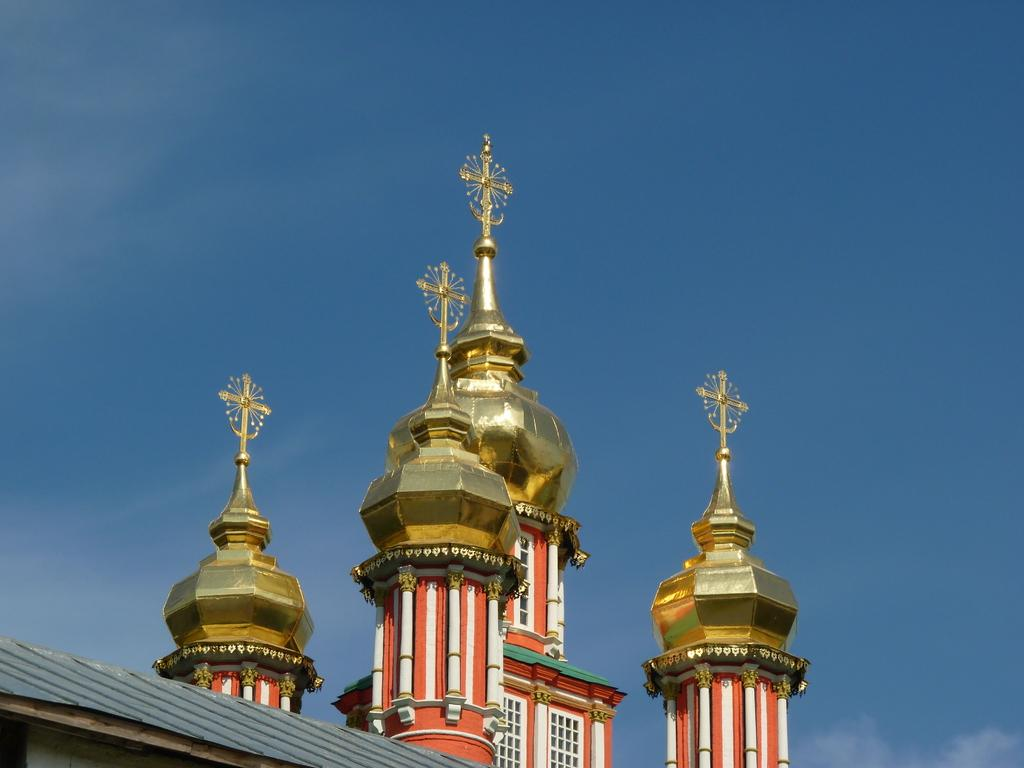What type of building is in the picture? There is a church in the picture. How many towers does the church have? The church has four towers. What is the color of the polish on the towers? The towers have a golden color polish. Are there any openings in the church walls? Yes, there are windows on the church. What is the condition of the sky in the picture? The sky is clear in the picture. What type of flight is taking off from the church in the image? There is no flight present in the image; it features a church with four towers. What kind of treatment is being administered to the church in the image? There is no treatment being administered to the church in the image; it is a static structure. 